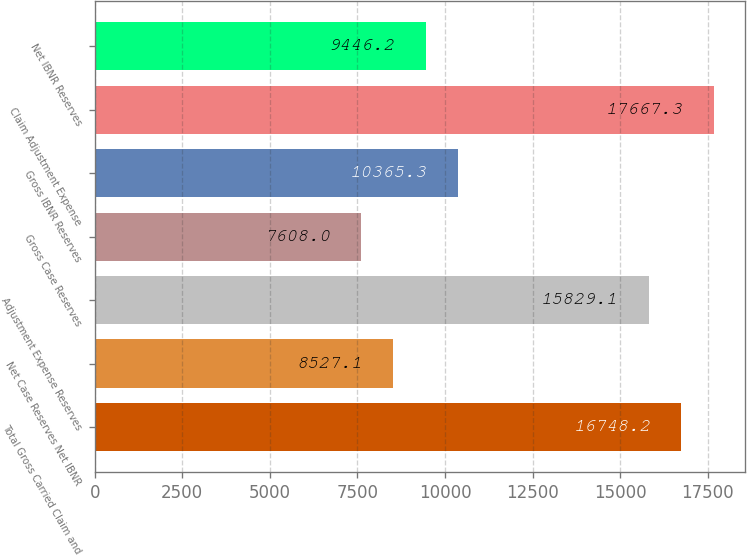<chart> <loc_0><loc_0><loc_500><loc_500><bar_chart><fcel>Total Gross Carried Claim and<fcel>Net Case Reserves Net IBNR<fcel>Adjustment Expense Reserves<fcel>Gross Case Reserves<fcel>Gross IBNR Reserves<fcel>Claim Adjustment Expense<fcel>Net IBNR Reserves<nl><fcel>16748.2<fcel>8527.1<fcel>15829.1<fcel>7608<fcel>10365.3<fcel>17667.3<fcel>9446.2<nl></chart> 